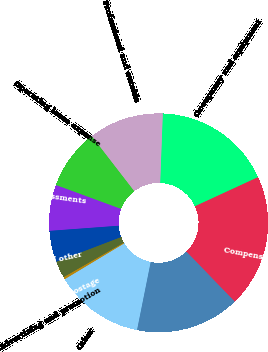Convert chart to OTSL. <chart><loc_0><loc_0><loc_500><loc_500><pie_chart><fcel>Compensation and benefits<fcel>Occupancy and equipment<fcel>Professional and outside<fcel>Operating lease expense<fcel>Regulatory assessments<fcel>Amortization of other<fcel>Stationery printing postage<fcel>Advertising and promotion<fcel>Other<fcel>Total other non-interest<nl><fcel>19.66%<fcel>17.52%<fcel>11.07%<fcel>8.93%<fcel>6.78%<fcel>4.63%<fcel>2.48%<fcel>0.34%<fcel>13.22%<fcel>15.37%<nl></chart> 